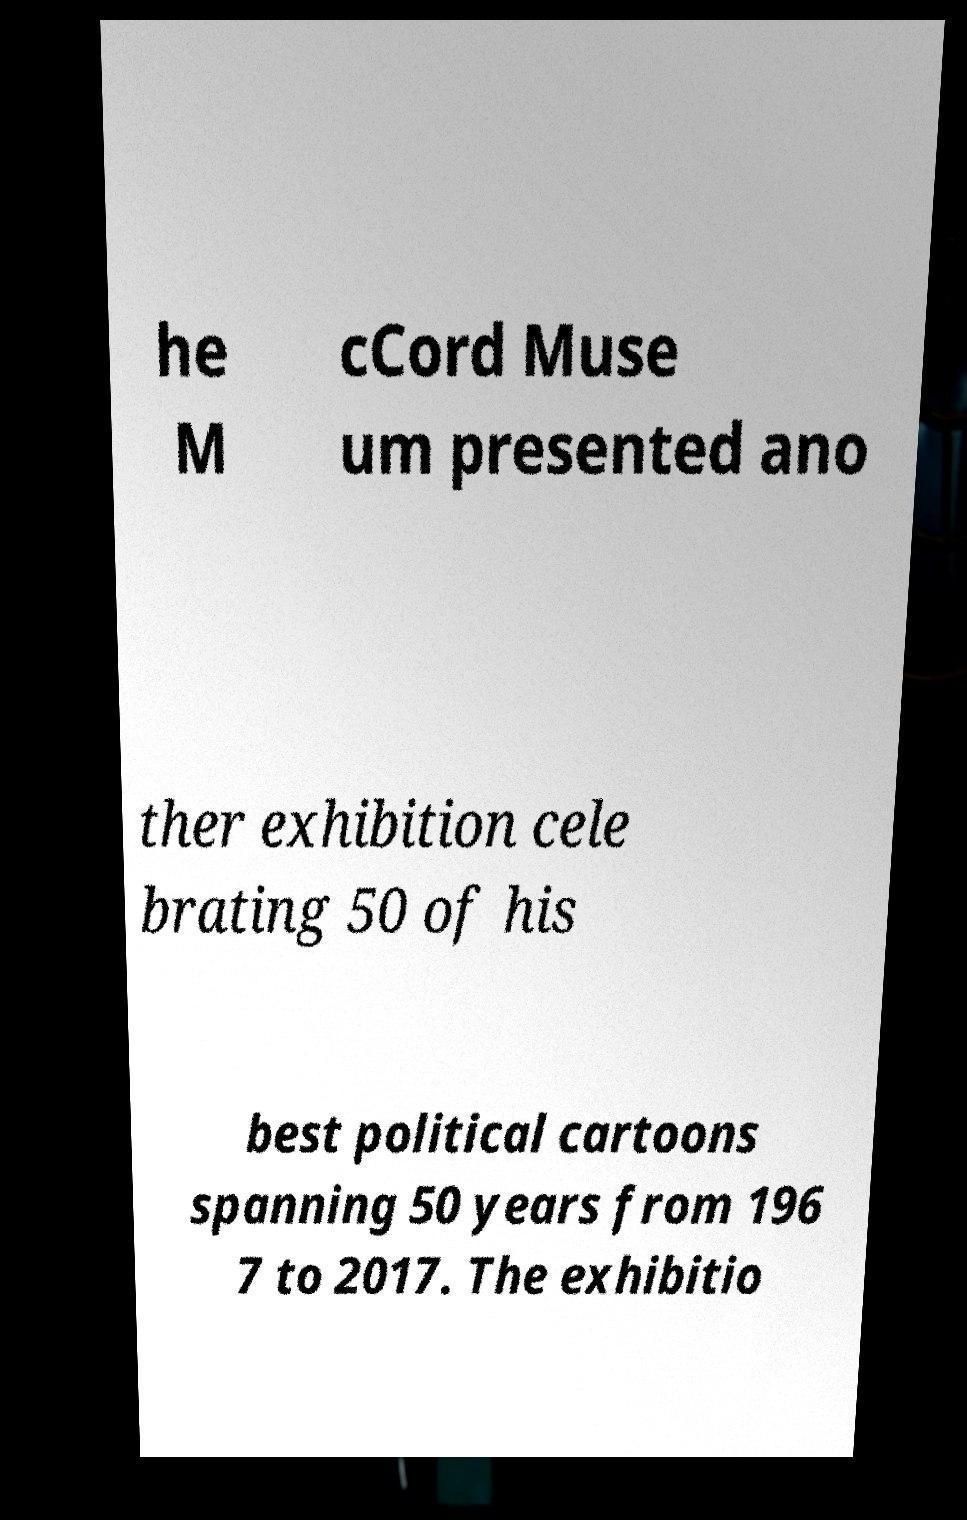Can you accurately transcribe the text from the provided image for me? he M cCord Muse um presented ano ther exhibition cele brating 50 of his best political cartoons spanning 50 years from 196 7 to 2017. The exhibitio 